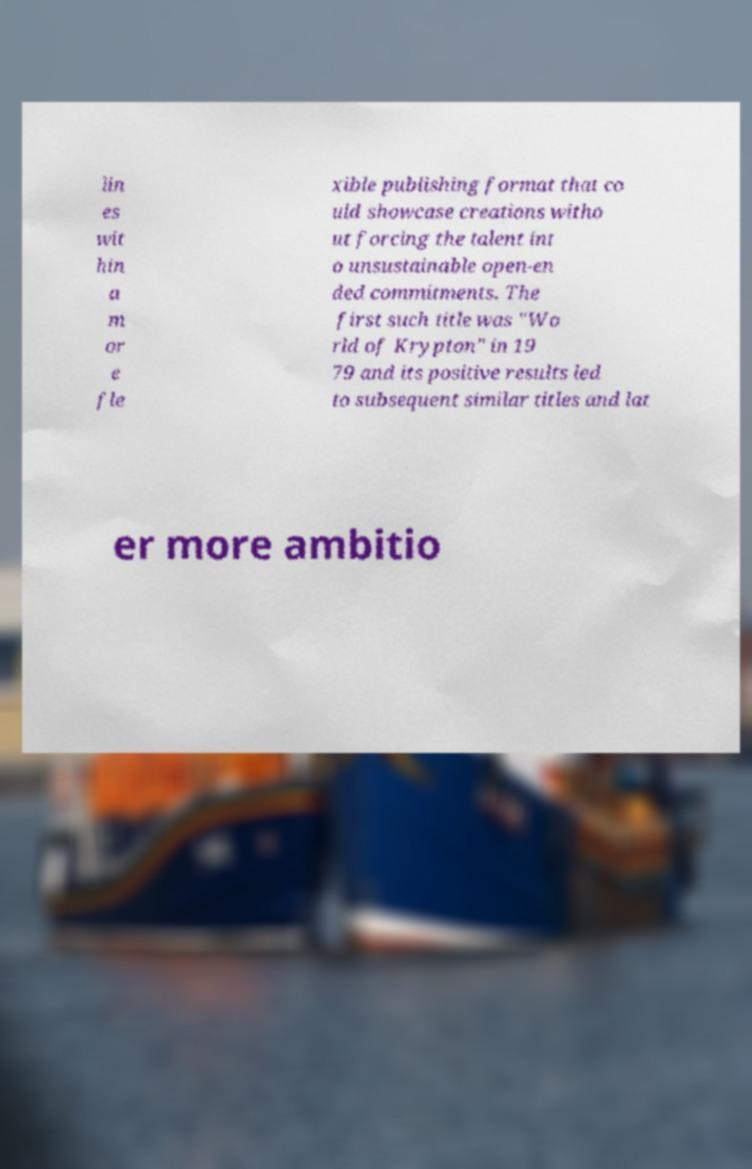Could you extract and type out the text from this image? lin es wit hin a m or e fle xible publishing format that co uld showcase creations witho ut forcing the talent int o unsustainable open-en ded commitments. The first such title was "Wo rld of Krypton" in 19 79 and its positive results led to subsequent similar titles and lat er more ambitio 